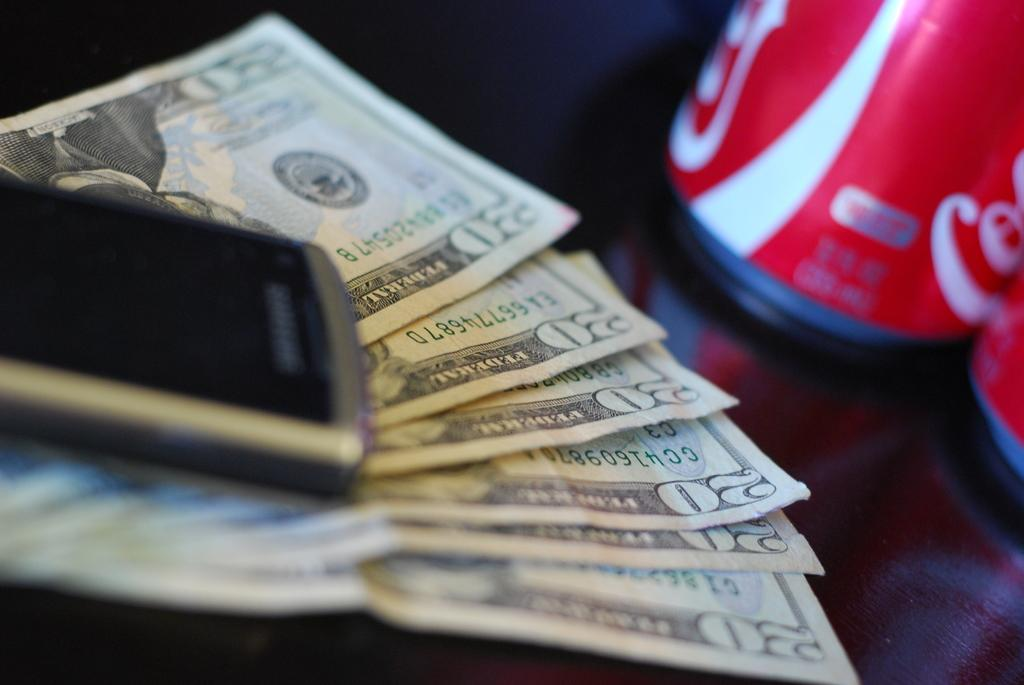What is present in the image along with the mobile phone? There are currency notes placed under the mobile phone in the image. What else can be seen in the right corner of the image? There are two tins in the right corner of the image. What type of honey is being produced by the coast in the image? There is no honey or coast present in the image; it features currency notes, a mobile phone, and two tins. 